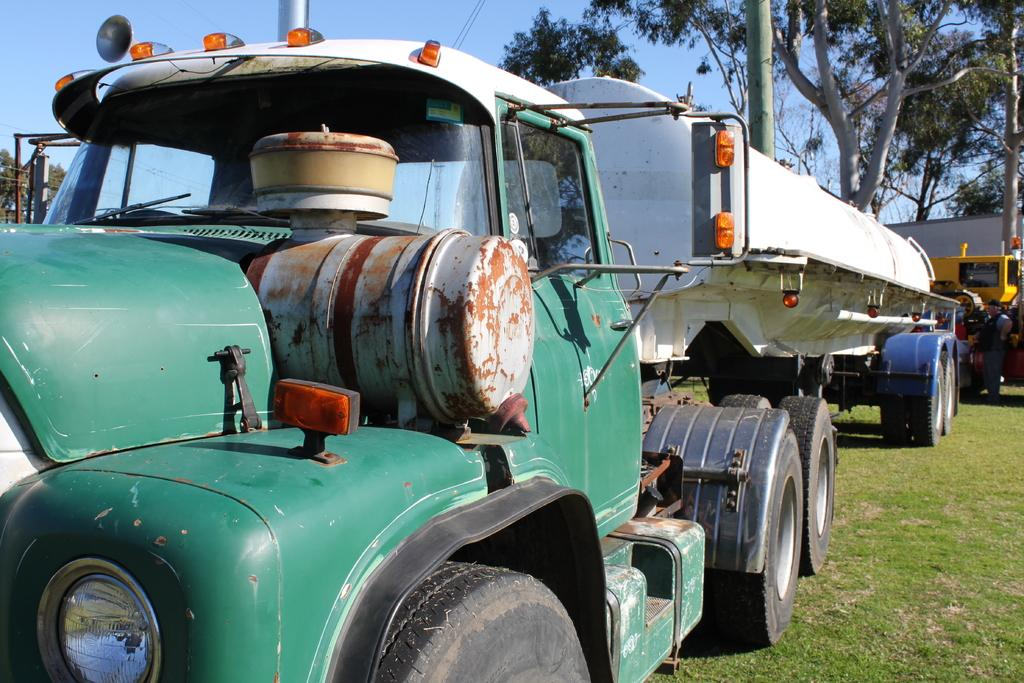What type of vehicle is in the image? There is a green and white color tanker in the image. Where is the tanker located? The tanker is on the ground. What can be seen in the background of the image? There are trees and the sky visible in the background of the image. What type of creature can be seen playing in the sand near the tanker in the image? There is no creature or sand present in the image; it only features a green and white color tanker on the ground with trees and the sky visible in the background. 